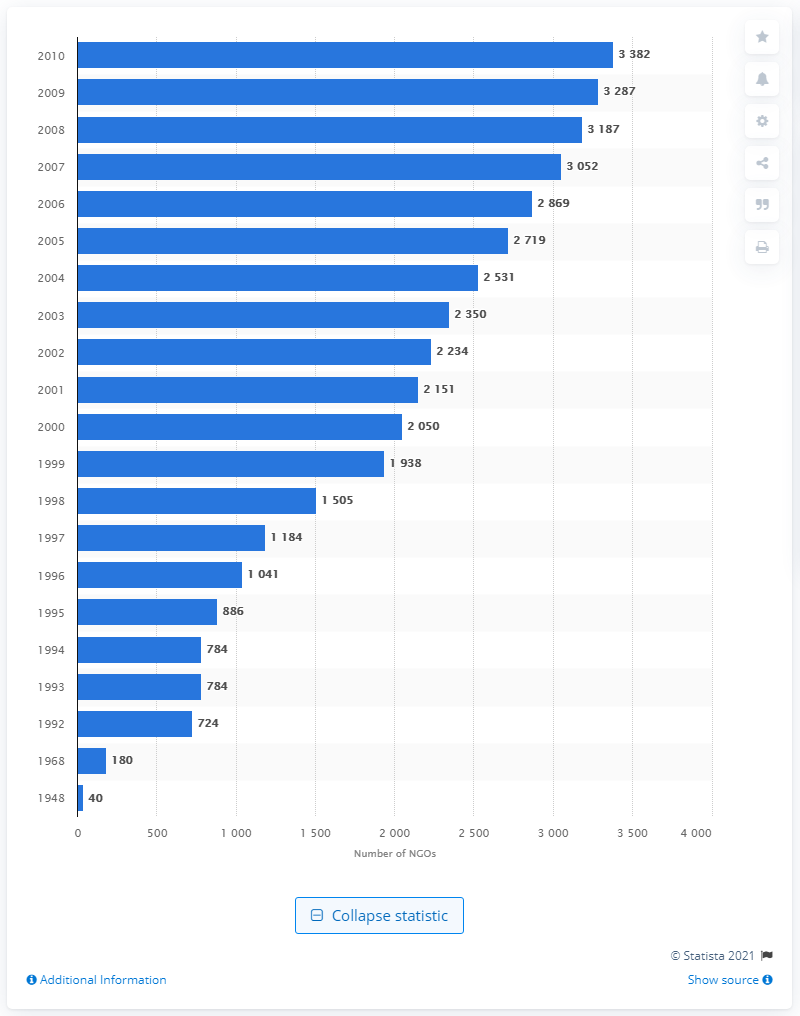Indicate a few pertinent items in this graphic. In 2010, there were 3,382 global organizations that held consultative status with the United Nations Economic and Social Council (ECOSOC). 